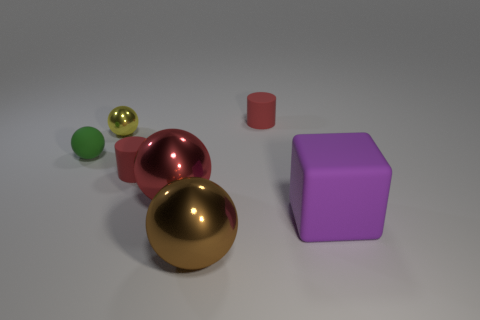Subtract all shiny spheres. How many spheres are left? 1 Add 1 small blue matte objects. How many objects exist? 8 Subtract all yellow balls. How many balls are left? 3 Subtract all blocks. Subtract all balls. How many objects are left? 2 Add 7 yellow spheres. How many yellow spheres are left? 8 Add 1 large green spheres. How many large green spheres exist? 1 Subtract 0 cyan cylinders. How many objects are left? 7 Subtract all cylinders. How many objects are left? 5 Subtract 2 spheres. How many spheres are left? 2 Subtract all green spheres. Subtract all gray blocks. How many spheres are left? 3 